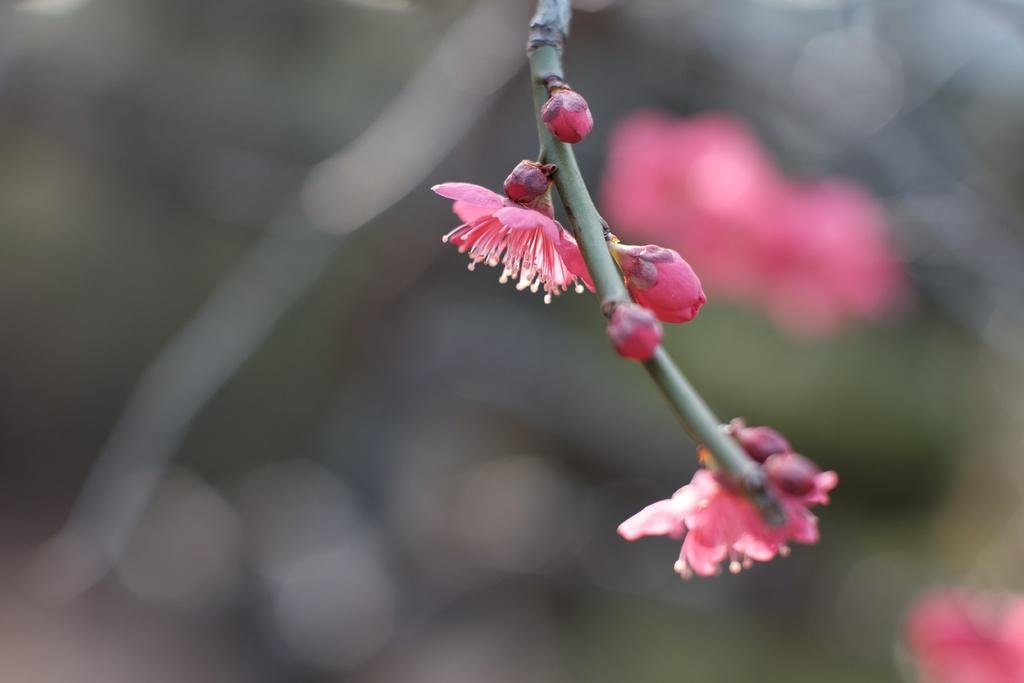What type of flowers can be seen in the image? There are pink flowers in the image. What stage of growth are the flowers in? There are buds in the image, indicating that some flowers are still in the process of blooming. What part of the flower is visible in the image? There is a stem in the image. How would you describe the background of the image? The background of the image is blurred. Can you see any toes in the image? There are no toes present in the image; it features pink flowers with buds and a stem against a blurred background. 